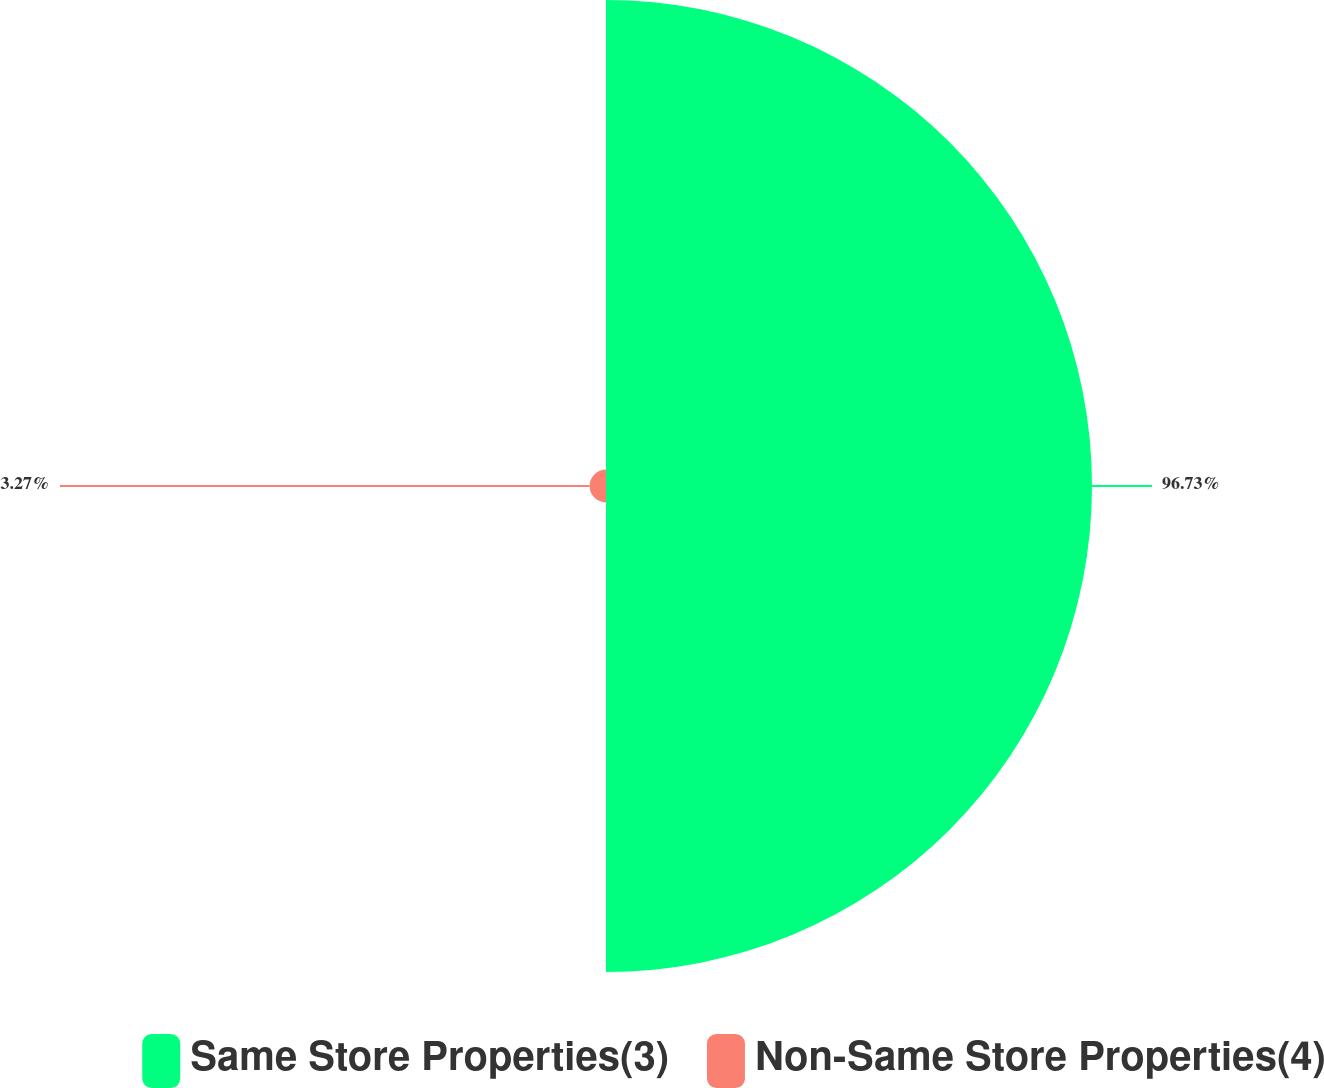Convert chart. <chart><loc_0><loc_0><loc_500><loc_500><pie_chart><fcel>Same Store Properties(3)<fcel>Non-Same Store Properties(4)<nl><fcel>96.73%<fcel>3.27%<nl></chart> 